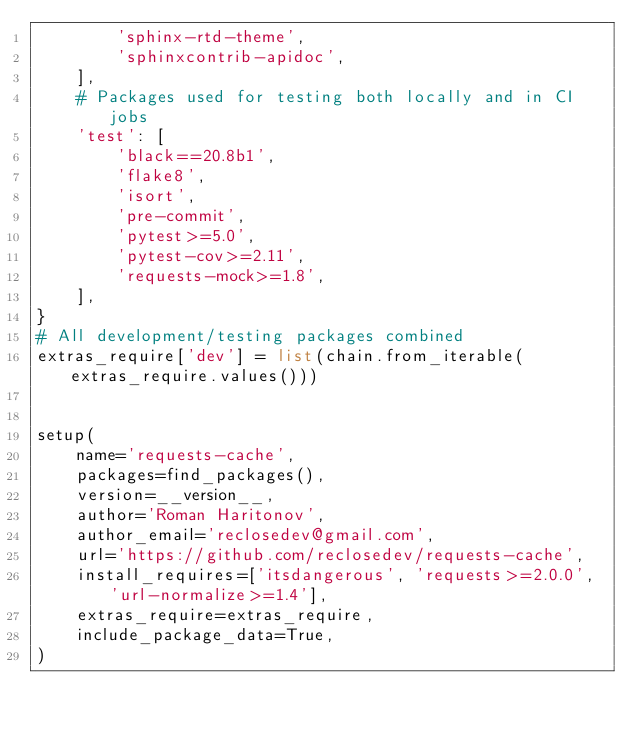<code> <loc_0><loc_0><loc_500><loc_500><_Python_>        'sphinx-rtd-theme',
        'sphinxcontrib-apidoc',
    ],
    # Packages used for testing both locally and in CI jobs
    'test': [
        'black==20.8b1',
        'flake8',
        'isort',
        'pre-commit',
        'pytest>=5.0',
        'pytest-cov>=2.11',
        'requests-mock>=1.8',
    ],
}
# All development/testing packages combined
extras_require['dev'] = list(chain.from_iterable(extras_require.values()))


setup(
    name='requests-cache',
    packages=find_packages(),
    version=__version__,
    author='Roman Haritonov',
    author_email='reclosedev@gmail.com',
    url='https://github.com/reclosedev/requests-cache',
    install_requires=['itsdangerous', 'requests>=2.0.0', 'url-normalize>=1.4'],
    extras_require=extras_require,
    include_package_data=True,
)
</code> 